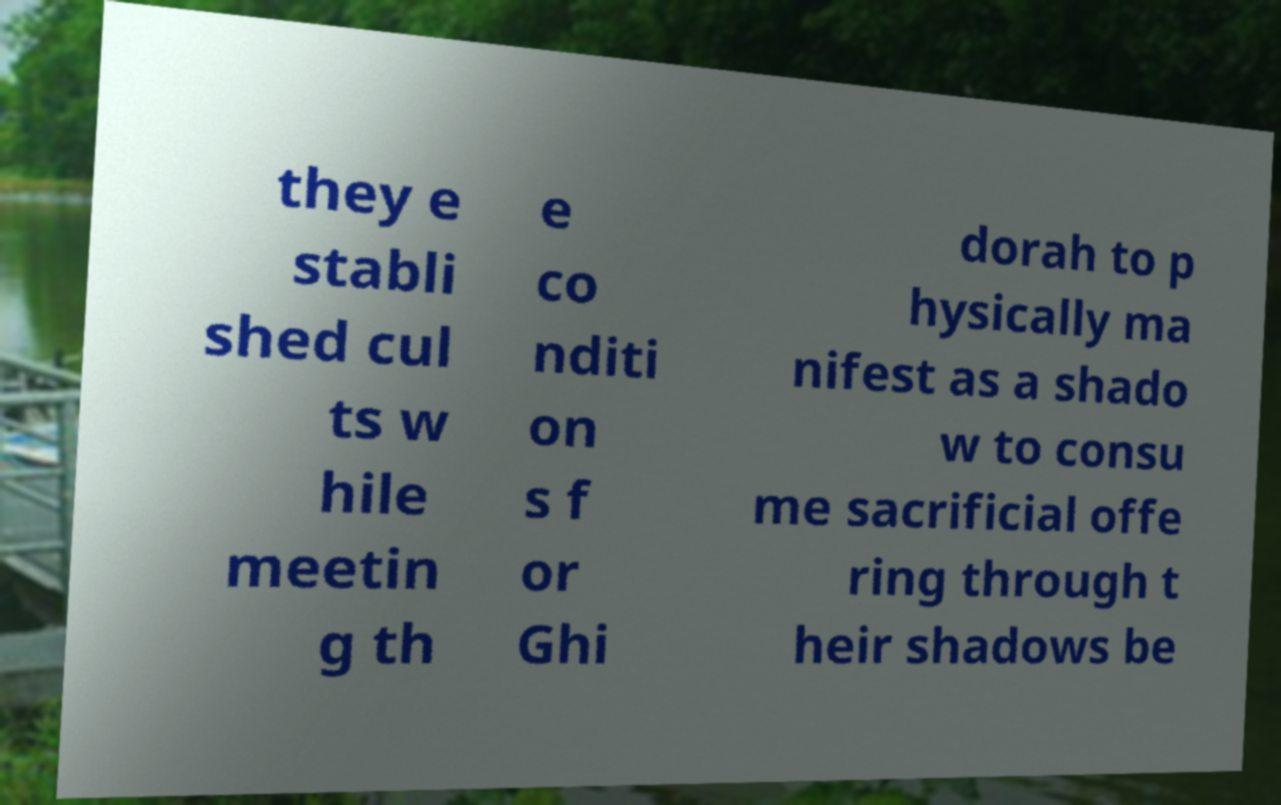Could you extract and type out the text from this image? they e stabli shed cul ts w hile meetin g th e co nditi on s f or Ghi dorah to p hysically ma nifest as a shado w to consu me sacrificial offe ring through t heir shadows be 